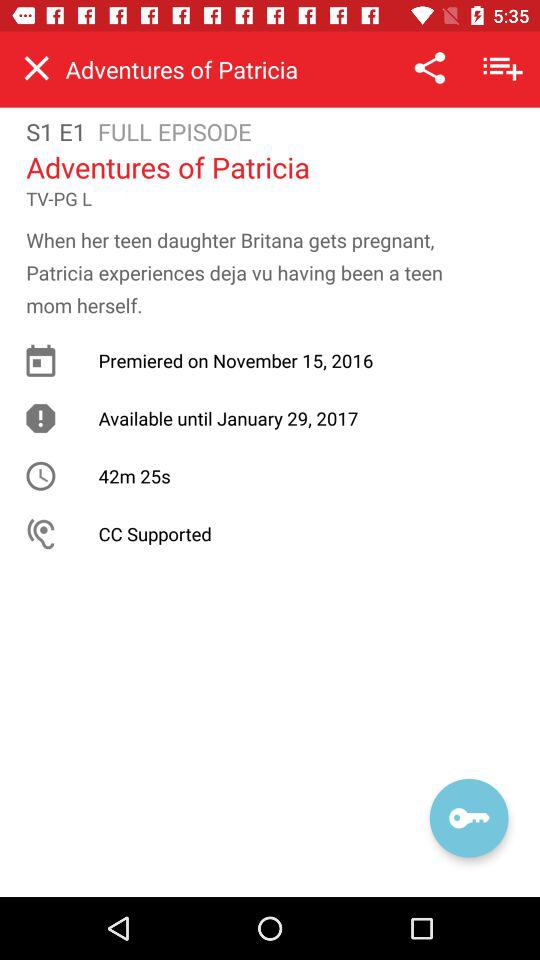The episode will be available until what date? The episode will be available until January 29, 2017. 